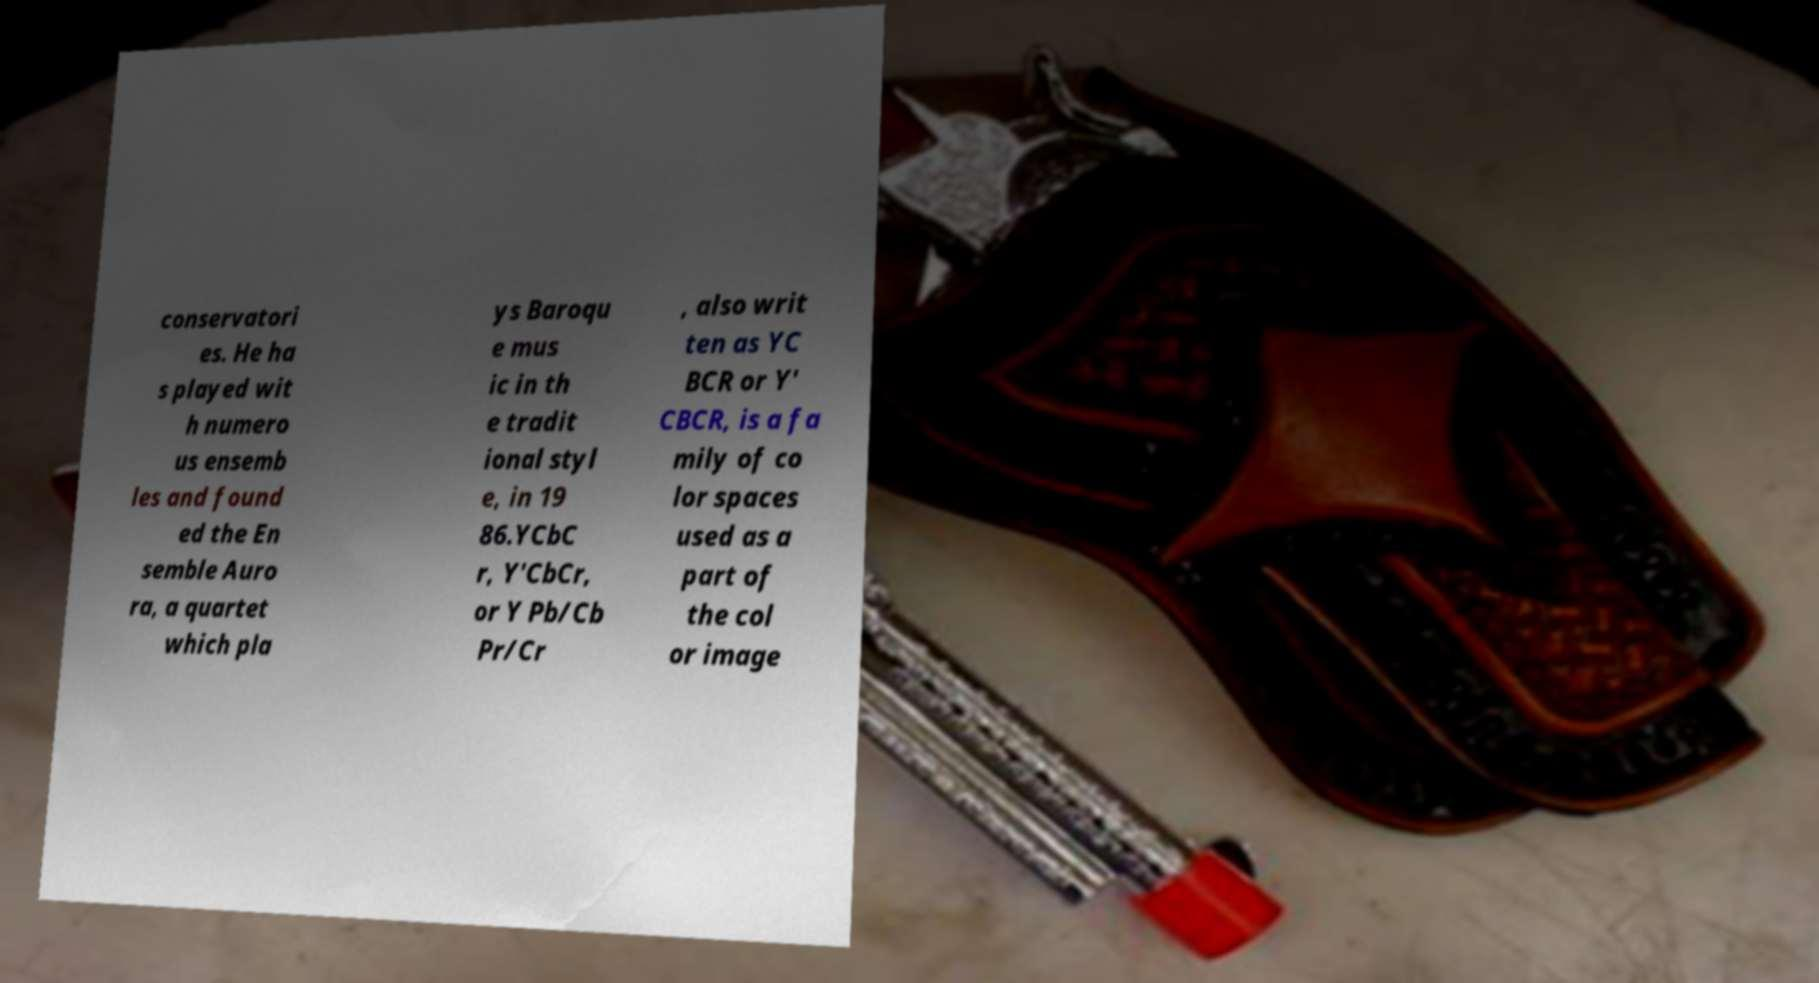For documentation purposes, I need the text within this image transcribed. Could you provide that? conservatori es. He ha s played wit h numero us ensemb les and found ed the En semble Auro ra, a quartet which pla ys Baroqu e mus ic in th e tradit ional styl e, in 19 86.YCbC r, Y′CbCr, or Y Pb/Cb Pr/Cr , also writ ten as YC BCR or Y′ CBCR, is a fa mily of co lor spaces used as a part of the col or image 